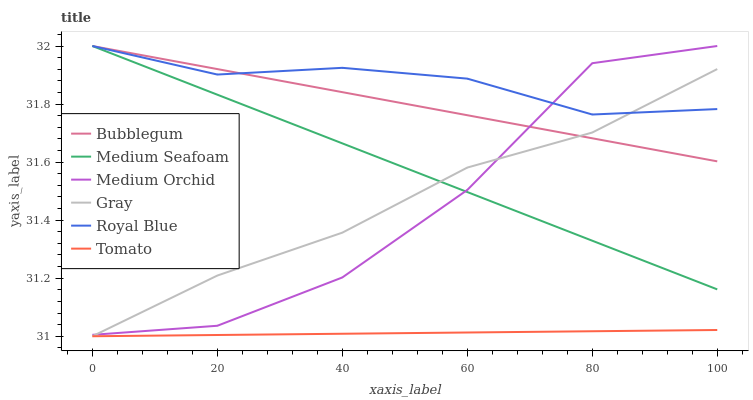Does Gray have the minimum area under the curve?
Answer yes or no. No. Does Gray have the maximum area under the curve?
Answer yes or no. No. Is Gray the smoothest?
Answer yes or no. No. Is Gray the roughest?
Answer yes or no. No. Does Medium Orchid have the lowest value?
Answer yes or no. No. Does Gray have the highest value?
Answer yes or no. No. Is Tomato less than Bubblegum?
Answer yes or no. Yes. Is Medium Seafoam greater than Tomato?
Answer yes or no. Yes. Does Tomato intersect Bubblegum?
Answer yes or no. No. 